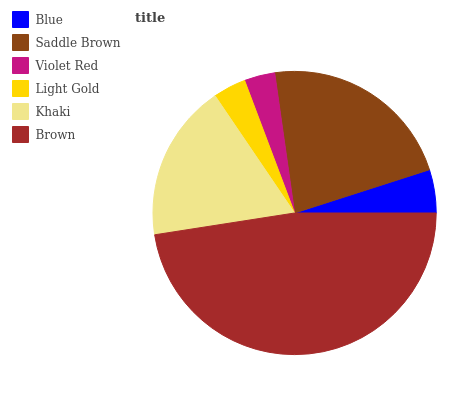Is Violet Red the minimum?
Answer yes or no. Yes. Is Brown the maximum?
Answer yes or no. Yes. Is Saddle Brown the minimum?
Answer yes or no. No. Is Saddle Brown the maximum?
Answer yes or no. No. Is Saddle Brown greater than Blue?
Answer yes or no. Yes. Is Blue less than Saddle Brown?
Answer yes or no. Yes. Is Blue greater than Saddle Brown?
Answer yes or no. No. Is Saddle Brown less than Blue?
Answer yes or no. No. Is Khaki the high median?
Answer yes or no. Yes. Is Blue the low median?
Answer yes or no. Yes. Is Brown the high median?
Answer yes or no. No. Is Brown the low median?
Answer yes or no. No. 